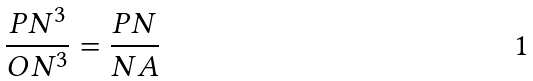Convert formula to latex. <formula><loc_0><loc_0><loc_500><loc_500>\frac { P N ^ { 3 } } { O N ^ { 3 } } = \frac { P N } { N A }</formula> 